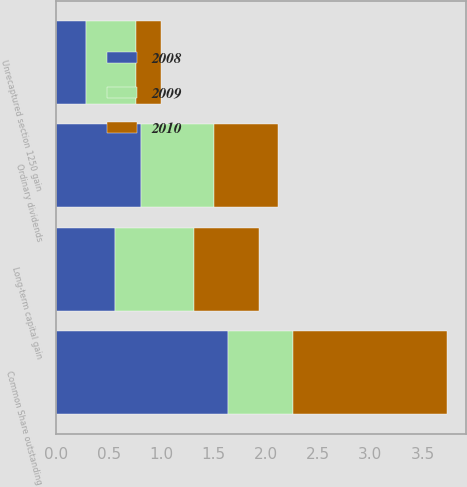<chart> <loc_0><loc_0><loc_500><loc_500><stacked_bar_chart><ecel><fcel>Ordinary dividends<fcel>Long-term capital gain<fcel>Unrecaptured section 1250 gain<fcel>Common Share outstanding<nl><fcel>2010<fcel>0.61<fcel>0.62<fcel>0.24<fcel>1.47<nl><fcel>2008<fcel>0.81<fcel>0.56<fcel>0.28<fcel>1.64<nl><fcel>2009<fcel>0.7<fcel>0.76<fcel>0.48<fcel>0.62<nl></chart> 